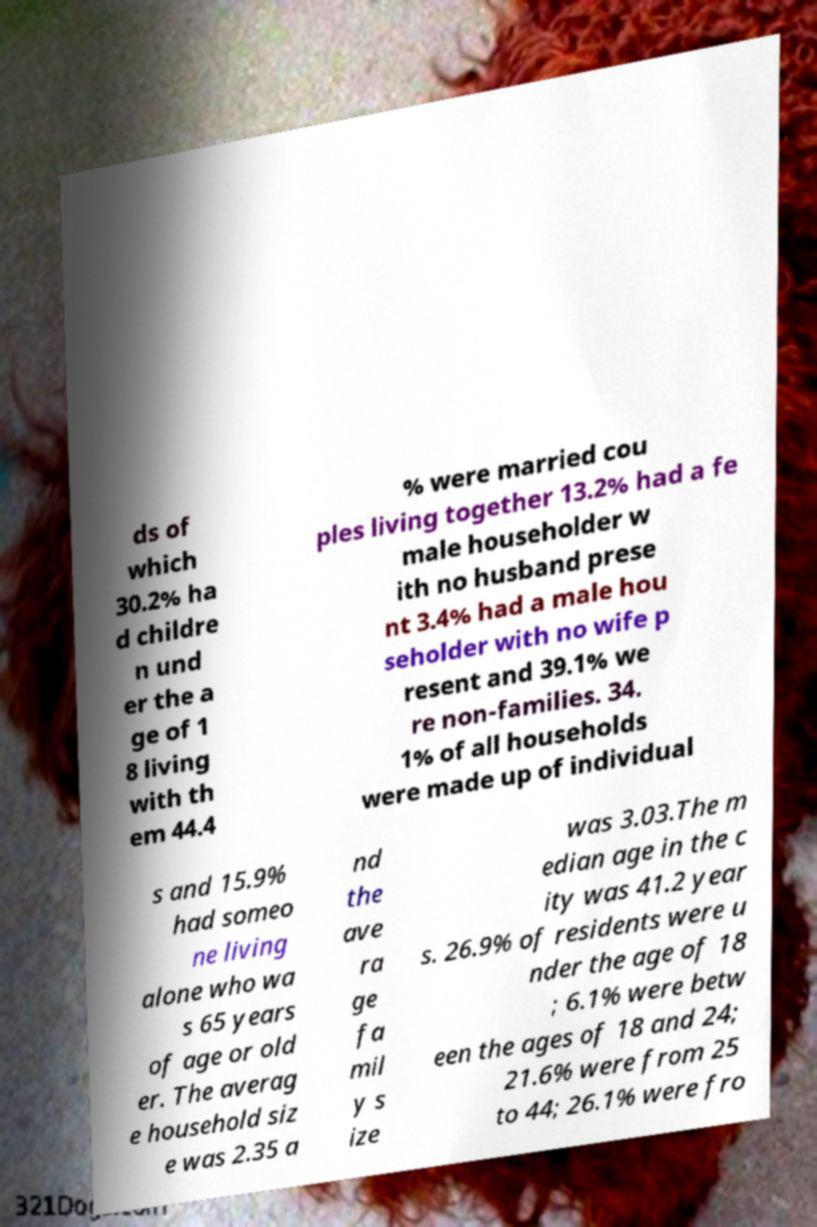I need the written content from this picture converted into text. Can you do that? ds of which 30.2% ha d childre n und er the a ge of 1 8 living with th em 44.4 % were married cou ples living together 13.2% had a fe male householder w ith no husband prese nt 3.4% had a male hou seholder with no wife p resent and 39.1% we re non-families. 34. 1% of all households were made up of individual s and 15.9% had someo ne living alone who wa s 65 years of age or old er. The averag e household siz e was 2.35 a nd the ave ra ge fa mil y s ize was 3.03.The m edian age in the c ity was 41.2 year s. 26.9% of residents were u nder the age of 18 ; 6.1% were betw een the ages of 18 and 24; 21.6% were from 25 to 44; 26.1% were fro 